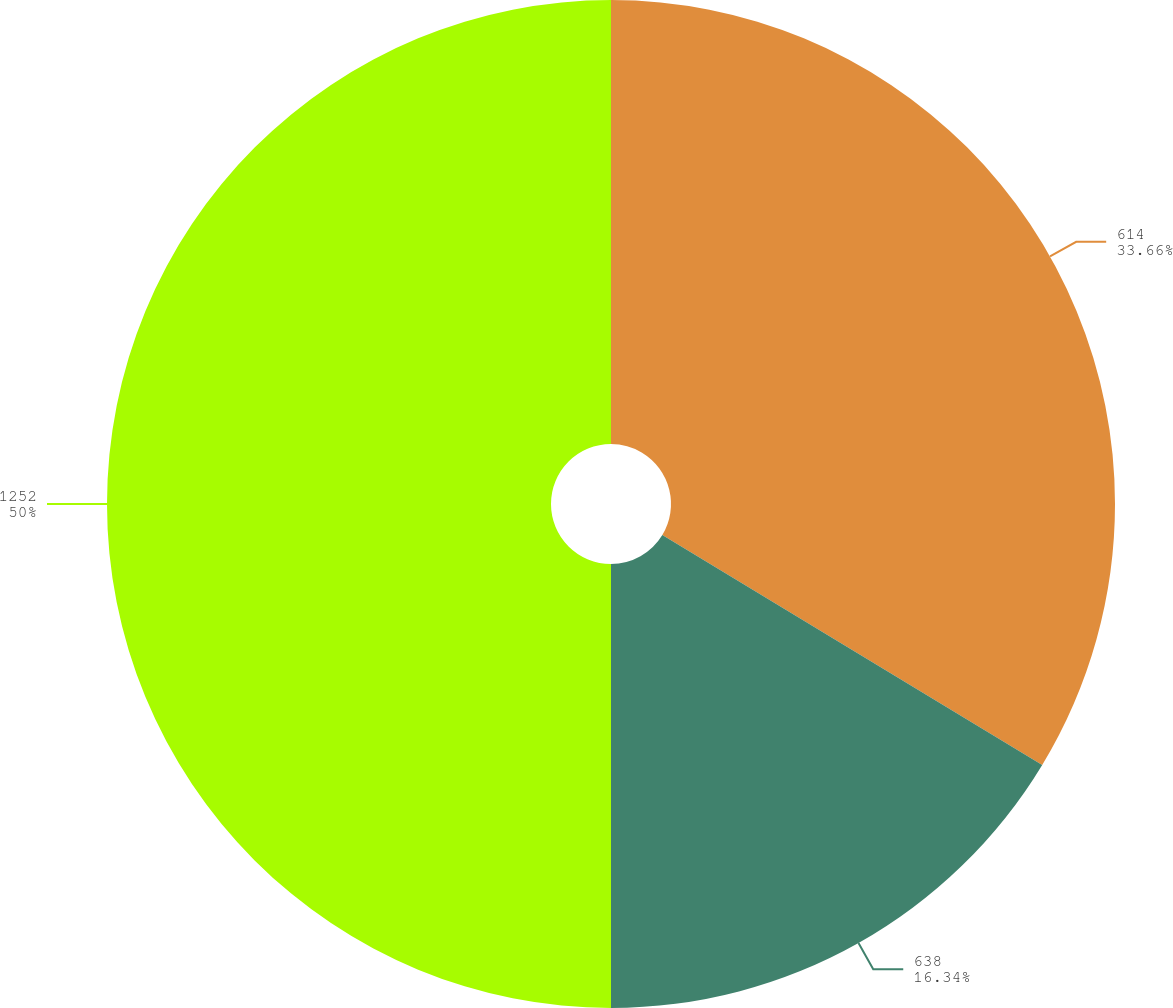<chart> <loc_0><loc_0><loc_500><loc_500><pie_chart><fcel>614<fcel>638<fcel>1252<nl><fcel>33.66%<fcel>16.34%<fcel>50.0%<nl></chart> 